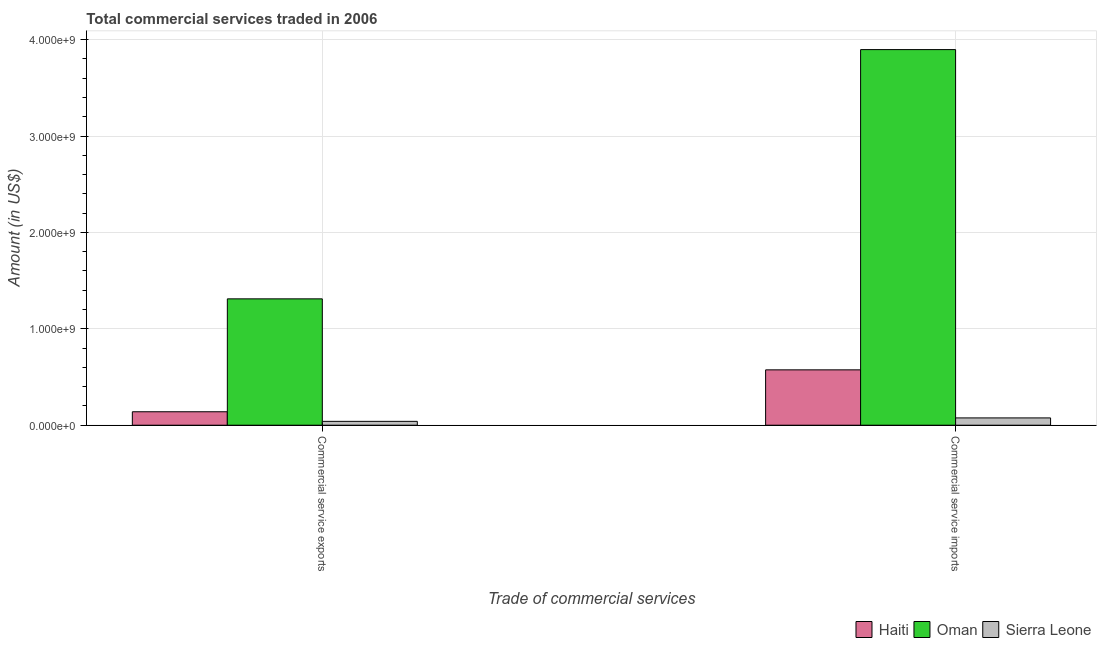How many different coloured bars are there?
Keep it short and to the point. 3. Are the number of bars on each tick of the X-axis equal?
Offer a terse response. Yes. How many bars are there on the 1st tick from the left?
Make the answer very short. 3. What is the label of the 2nd group of bars from the left?
Make the answer very short. Commercial service imports. What is the amount of commercial service exports in Sierra Leone?
Ensure brevity in your answer.  4.00e+07. Across all countries, what is the maximum amount of commercial service imports?
Make the answer very short. 3.90e+09. Across all countries, what is the minimum amount of commercial service exports?
Give a very brief answer. 4.00e+07. In which country was the amount of commercial service exports maximum?
Your answer should be very brief. Oman. In which country was the amount of commercial service imports minimum?
Your response must be concise. Sierra Leone. What is the total amount of commercial service exports in the graph?
Make the answer very short. 1.49e+09. What is the difference between the amount of commercial service exports in Oman and that in Sierra Leone?
Your response must be concise. 1.27e+09. What is the difference between the amount of commercial service imports in Sierra Leone and the amount of commercial service exports in Haiti?
Give a very brief answer. -6.38e+07. What is the average amount of commercial service exports per country?
Your answer should be compact. 4.97e+08. What is the difference between the amount of commercial service exports and amount of commercial service imports in Oman?
Offer a very short reply. -2.59e+09. What is the ratio of the amount of commercial service imports in Haiti to that in Oman?
Provide a short and direct response. 0.15. Is the amount of commercial service imports in Haiti less than that in Oman?
Ensure brevity in your answer.  Yes. What does the 2nd bar from the left in Commercial service exports represents?
Make the answer very short. Oman. What does the 3rd bar from the right in Commercial service imports represents?
Provide a short and direct response. Haiti. Are all the bars in the graph horizontal?
Keep it short and to the point. No. What is the difference between two consecutive major ticks on the Y-axis?
Offer a terse response. 1.00e+09. Are the values on the major ticks of Y-axis written in scientific E-notation?
Make the answer very short. Yes. How many legend labels are there?
Your response must be concise. 3. How are the legend labels stacked?
Ensure brevity in your answer.  Horizontal. What is the title of the graph?
Make the answer very short. Total commercial services traded in 2006. Does "Comoros" appear as one of the legend labels in the graph?
Your answer should be compact. No. What is the label or title of the X-axis?
Offer a terse response. Trade of commercial services. What is the label or title of the Y-axis?
Offer a very short reply. Amount (in US$). What is the Amount (in US$) of Haiti in Commercial service exports?
Keep it short and to the point. 1.40e+08. What is the Amount (in US$) of Oman in Commercial service exports?
Your answer should be very brief. 1.31e+09. What is the Amount (in US$) of Sierra Leone in Commercial service exports?
Give a very brief answer. 4.00e+07. What is the Amount (in US$) of Haiti in Commercial service imports?
Offer a very short reply. 5.74e+08. What is the Amount (in US$) of Oman in Commercial service imports?
Provide a short and direct response. 3.90e+09. What is the Amount (in US$) of Sierra Leone in Commercial service imports?
Keep it short and to the point. 7.57e+07. Across all Trade of commercial services, what is the maximum Amount (in US$) of Haiti?
Give a very brief answer. 5.74e+08. Across all Trade of commercial services, what is the maximum Amount (in US$) of Oman?
Your answer should be compact. 3.90e+09. Across all Trade of commercial services, what is the maximum Amount (in US$) of Sierra Leone?
Give a very brief answer. 7.57e+07. Across all Trade of commercial services, what is the minimum Amount (in US$) in Haiti?
Your response must be concise. 1.40e+08. Across all Trade of commercial services, what is the minimum Amount (in US$) of Oman?
Keep it short and to the point. 1.31e+09. Across all Trade of commercial services, what is the minimum Amount (in US$) of Sierra Leone?
Your response must be concise. 4.00e+07. What is the total Amount (in US$) of Haiti in the graph?
Provide a short and direct response. 7.14e+08. What is the total Amount (in US$) in Oman in the graph?
Offer a terse response. 5.21e+09. What is the total Amount (in US$) in Sierra Leone in the graph?
Ensure brevity in your answer.  1.16e+08. What is the difference between the Amount (in US$) in Haiti in Commercial service exports and that in Commercial service imports?
Your answer should be compact. -4.35e+08. What is the difference between the Amount (in US$) in Oman in Commercial service exports and that in Commercial service imports?
Give a very brief answer. -2.59e+09. What is the difference between the Amount (in US$) in Sierra Leone in Commercial service exports and that in Commercial service imports?
Keep it short and to the point. -3.57e+07. What is the difference between the Amount (in US$) in Haiti in Commercial service exports and the Amount (in US$) in Oman in Commercial service imports?
Provide a succinct answer. -3.76e+09. What is the difference between the Amount (in US$) of Haiti in Commercial service exports and the Amount (in US$) of Sierra Leone in Commercial service imports?
Make the answer very short. 6.38e+07. What is the difference between the Amount (in US$) in Oman in Commercial service exports and the Amount (in US$) in Sierra Leone in Commercial service imports?
Give a very brief answer. 1.24e+09. What is the average Amount (in US$) in Haiti per Trade of commercial services?
Your answer should be compact. 3.57e+08. What is the average Amount (in US$) in Oman per Trade of commercial services?
Keep it short and to the point. 2.60e+09. What is the average Amount (in US$) in Sierra Leone per Trade of commercial services?
Make the answer very short. 5.79e+07. What is the difference between the Amount (in US$) of Haiti and Amount (in US$) of Oman in Commercial service exports?
Your response must be concise. -1.17e+09. What is the difference between the Amount (in US$) of Haiti and Amount (in US$) of Sierra Leone in Commercial service exports?
Keep it short and to the point. 9.95e+07. What is the difference between the Amount (in US$) in Oman and Amount (in US$) in Sierra Leone in Commercial service exports?
Offer a terse response. 1.27e+09. What is the difference between the Amount (in US$) of Haiti and Amount (in US$) of Oman in Commercial service imports?
Give a very brief answer. -3.32e+09. What is the difference between the Amount (in US$) in Haiti and Amount (in US$) in Sierra Leone in Commercial service imports?
Give a very brief answer. 4.99e+08. What is the difference between the Amount (in US$) in Oman and Amount (in US$) in Sierra Leone in Commercial service imports?
Keep it short and to the point. 3.82e+09. What is the ratio of the Amount (in US$) in Haiti in Commercial service exports to that in Commercial service imports?
Keep it short and to the point. 0.24. What is the ratio of the Amount (in US$) of Oman in Commercial service exports to that in Commercial service imports?
Your answer should be compact. 0.34. What is the ratio of the Amount (in US$) in Sierra Leone in Commercial service exports to that in Commercial service imports?
Offer a very short reply. 0.53. What is the difference between the highest and the second highest Amount (in US$) in Haiti?
Your answer should be very brief. 4.35e+08. What is the difference between the highest and the second highest Amount (in US$) of Oman?
Make the answer very short. 2.59e+09. What is the difference between the highest and the second highest Amount (in US$) of Sierra Leone?
Your answer should be very brief. 3.57e+07. What is the difference between the highest and the lowest Amount (in US$) of Haiti?
Provide a succinct answer. 4.35e+08. What is the difference between the highest and the lowest Amount (in US$) in Oman?
Your response must be concise. 2.59e+09. What is the difference between the highest and the lowest Amount (in US$) in Sierra Leone?
Provide a succinct answer. 3.57e+07. 